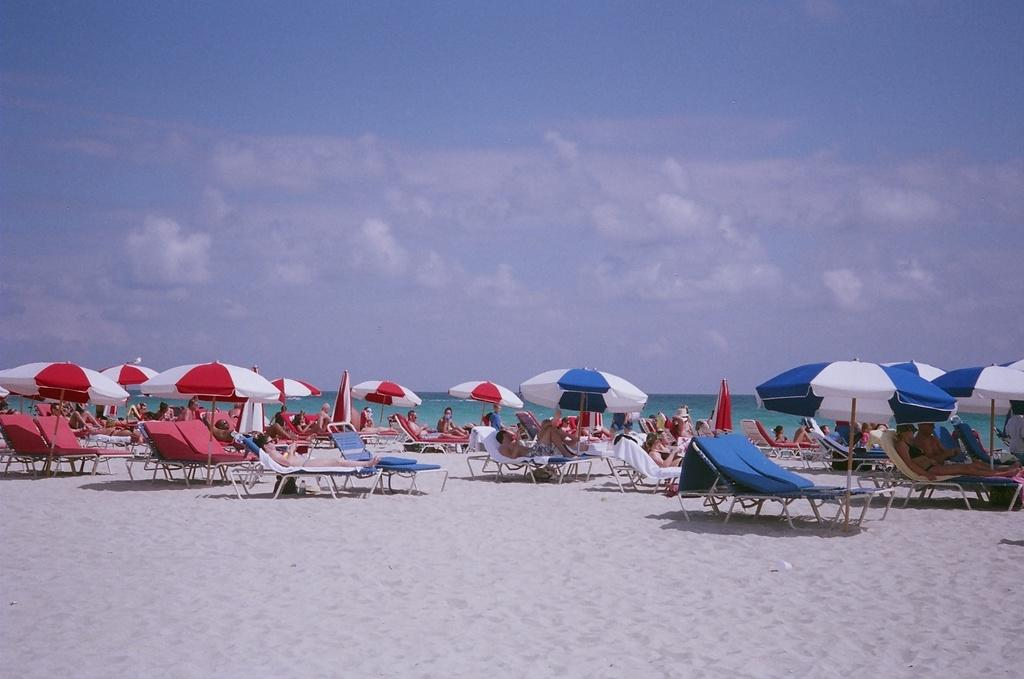What type of furniture is visible in the image? There are chairs in the image. What are the people doing in the image? There are people on cars in the image. What can be seen on the beach in the image? There are umbrellas on the beach in the image. What is visible in the sky in the image? The sky is visible in the image, and clouds are present. Can you describe the beggar in the image? There is no beggar present in the image. What type of scene is depicted in the image? The image does not depict a specific scene; it shows chairs, people on cars, umbrellas on the beach, and the sky with clouds. 